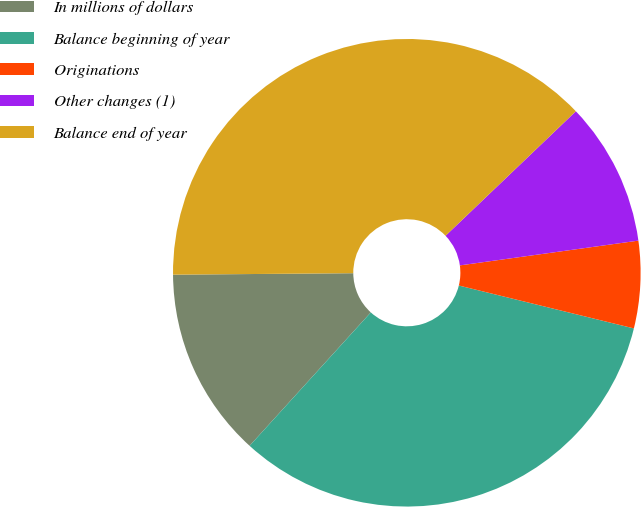Convert chart to OTSL. <chart><loc_0><loc_0><loc_500><loc_500><pie_chart><fcel>In millions of dollars<fcel>Balance beginning of year<fcel>Originations<fcel>Other changes (1)<fcel>Balance end of year<nl><fcel>13.13%<fcel>32.91%<fcel>6.02%<fcel>9.94%<fcel>37.99%<nl></chart> 